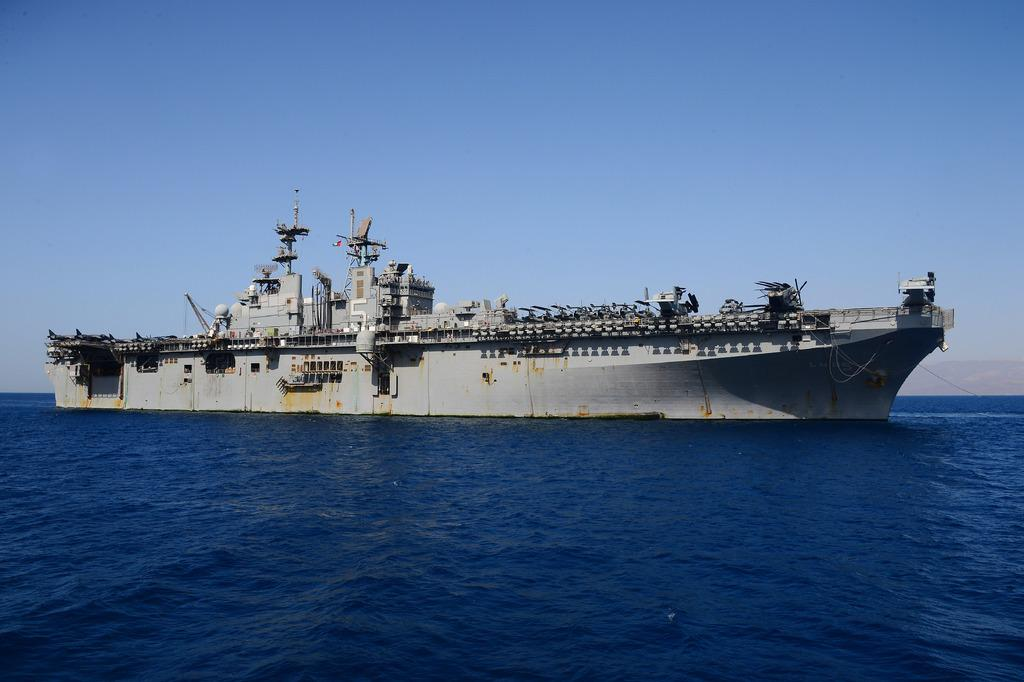What is the main subject of the image? The main subject of the image is a big ship. What color is the ship? The ship is gray in color. What is at the bottom of the image? There is water at the bottom of the image. What is visible at the top of the image? The sky is visible at the top of the image. What type of steel is used to construct the train in the image? There is no train present in the image; it features a big ship. How does the regret of the captain affect the ship's navigation in the image? There is no indication of the captain's emotions or regret in the image, so it cannot be determined how it affects the ship's navigation. 